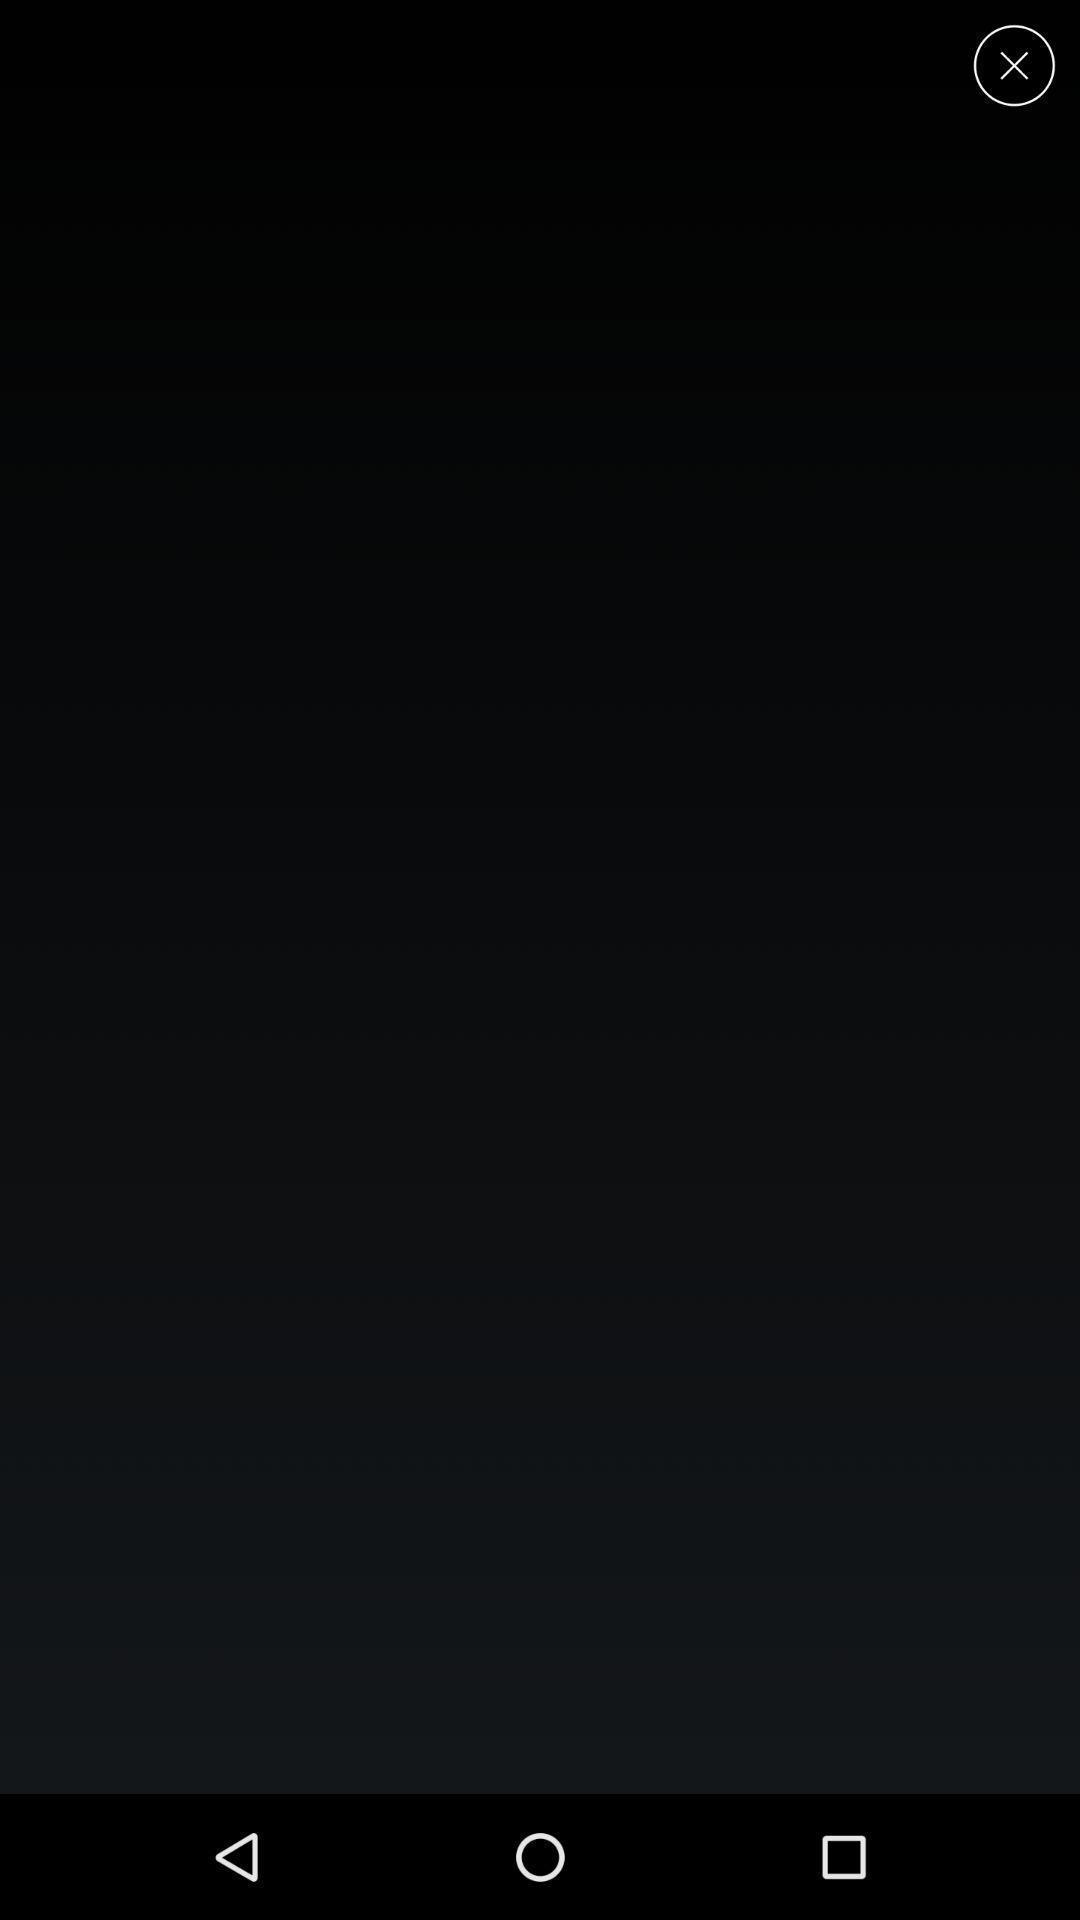Describe the visual elements of this screenshot. Screen shows blank page. 